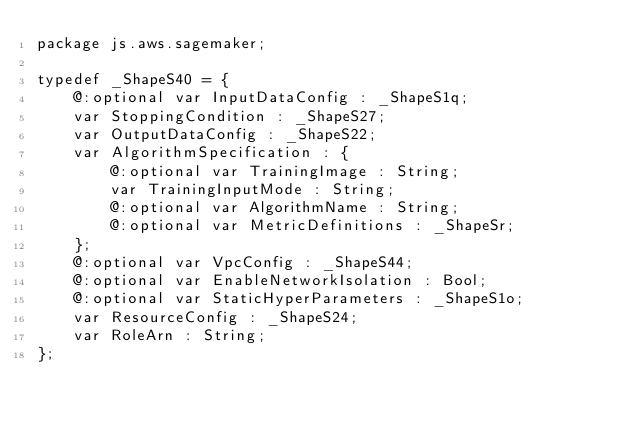<code> <loc_0><loc_0><loc_500><loc_500><_Haxe_>package js.aws.sagemaker;

typedef _ShapeS40 = {
    @:optional var InputDataConfig : _ShapeS1q;
    var StoppingCondition : _ShapeS27;
    var OutputDataConfig : _ShapeS22;
    var AlgorithmSpecification : {
        @:optional var TrainingImage : String;
        var TrainingInputMode : String;
        @:optional var AlgorithmName : String;
        @:optional var MetricDefinitions : _ShapeSr;
    };
    @:optional var VpcConfig : _ShapeS44;
    @:optional var EnableNetworkIsolation : Bool;
    @:optional var StaticHyperParameters : _ShapeS1o;
    var ResourceConfig : _ShapeS24;
    var RoleArn : String;
};
</code> 